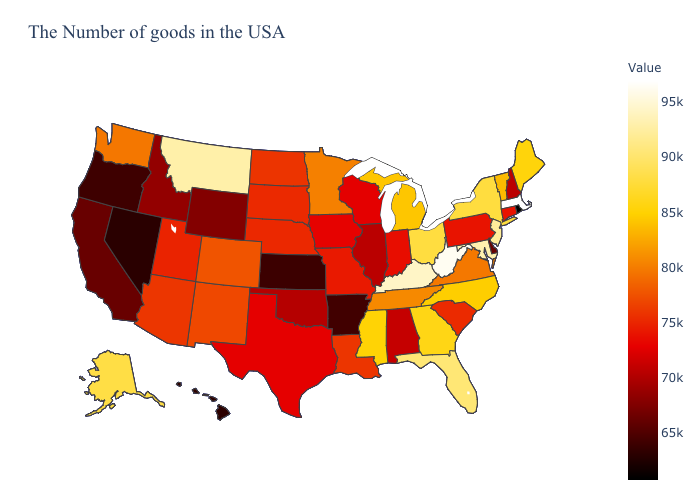Which states hav the highest value in the West?
Give a very brief answer. Montana. Does California have a lower value than Rhode Island?
Answer briefly. No. Among the states that border Michigan , does Ohio have the highest value?
Be succinct. Yes. Does Massachusetts have the highest value in the USA?
Write a very short answer. Yes. Does South Carolina have a lower value than Arkansas?
Quick response, please. No. Which states have the highest value in the USA?
Short answer required. Massachusetts. Which states have the lowest value in the West?
Concise answer only. Nevada. Does Wisconsin have a higher value than Wyoming?
Answer briefly. Yes. 